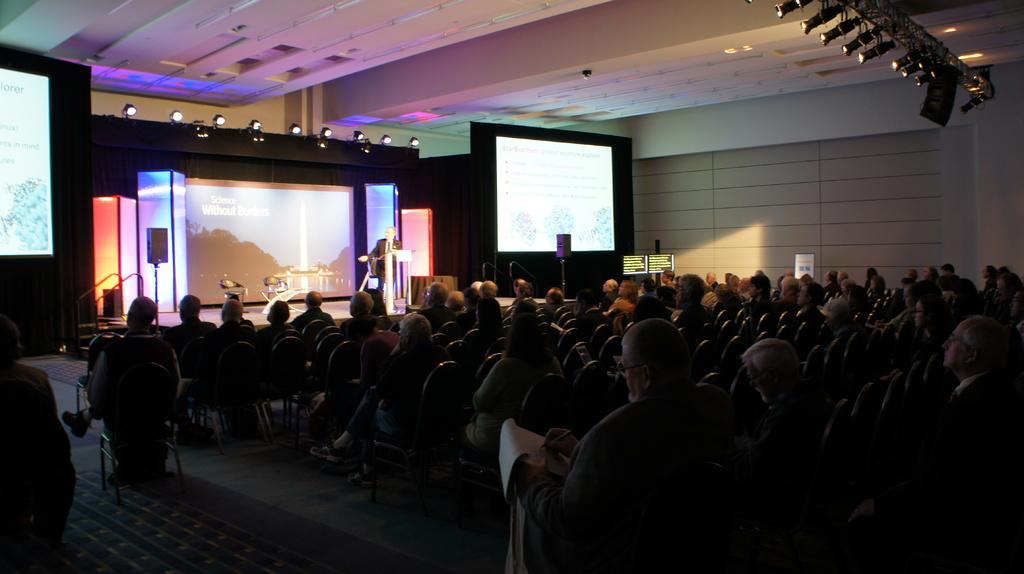Please provide a concise description of this image. Here in this picture in the front we can see number of people sitting on chairs present on the floor and in front of them we can see a stage, on which we can see a person standing and speaking something in the microphone present on the speech desk in front of him and we can also see a couple of chairs present and we can see a projector screen in the middle with something projected on it and we can also see speakers present on the either side of the stage and we can also see the projector screens on the either side of the stage with something projected on it and we can see lights projected on the top on the either side. 